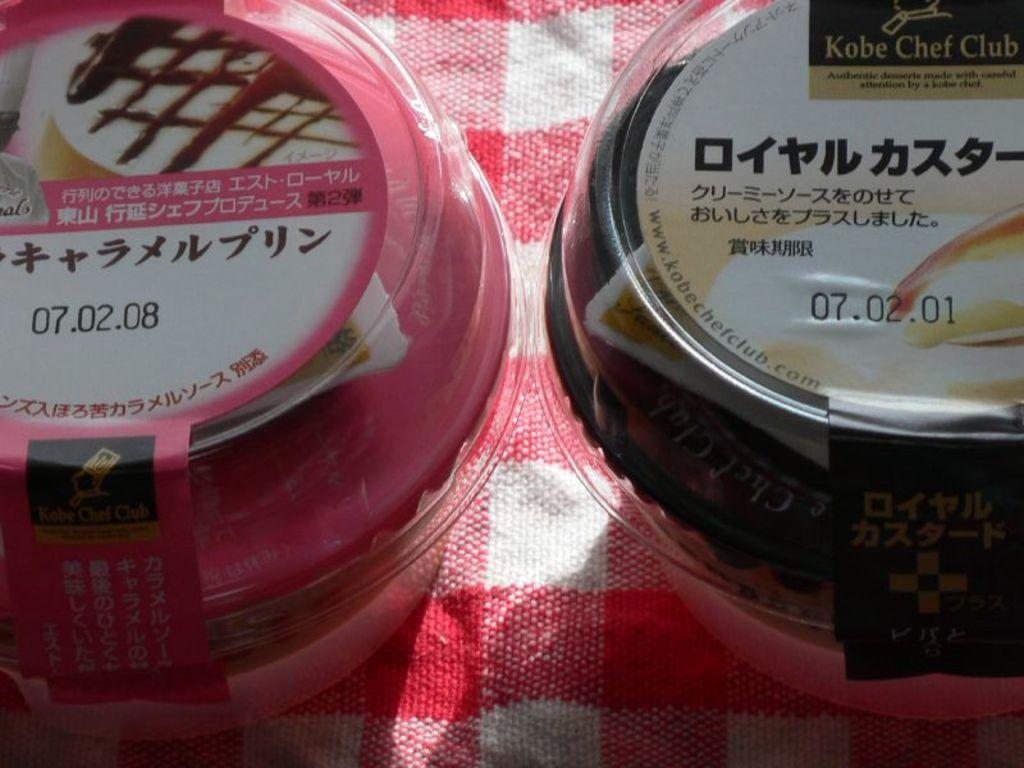<image>
Offer a succinct explanation of the picture presented. A pie that is dated zero seven dot Oh two dot Oh eight 